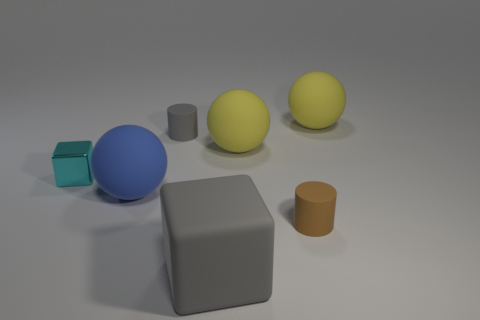Does the cyan cube have the same material as the tiny thing that is in front of the big blue rubber sphere? Upon examining the image, it appears that the cyan cube and the small object in front of the large blue sphere do not share the same material. The cyan cube displays a metallic sheen indicative of a reflective material, while the tiny object has a matte finish, suggesting a non-reflective, possibly rubber-like material. 